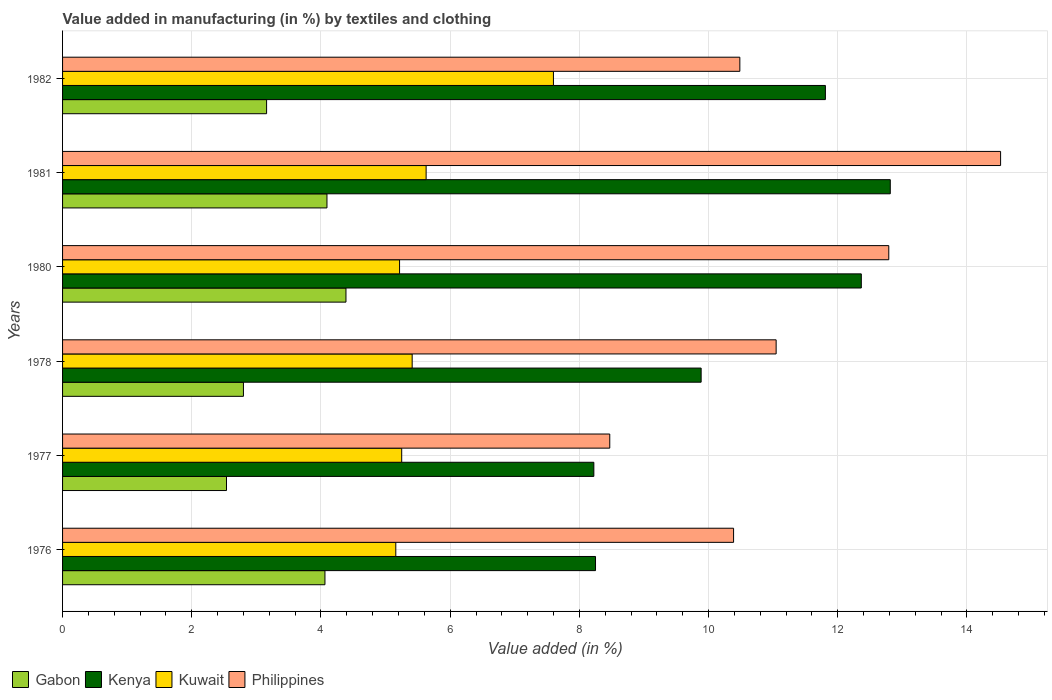Are the number of bars per tick equal to the number of legend labels?
Give a very brief answer. Yes. Are the number of bars on each tick of the Y-axis equal?
Your answer should be compact. Yes. What is the label of the 1st group of bars from the top?
Your answer should be very brief. 1982. What is the percentage of value added in manufacturing by textiles and clothing in Kenya in 1981?
Give a very brief answer. 12.81. Across all years, what is the maximum percentage of value added in manufacturing by textiles and clothing in Gabon?
Provide a short and direct response. 4.39. Across all years, what is the minimum percentage of value added in manufacturing by textiles and clothing in Philippines?
Keep it short and to the point. 8.47. In which year was the percentage of value added in manufacturing by textiles and clothing in Kuwait minimum?
Provide a short and direct response. 1976. What is the total percentage of value added in manufacturing by textiles and clothing in Kenya in the graph?
Ensure brevity in your answer.  63.34. What is the difference between the percentage of value added in manufacturing by textiles and clothing in Kuwait in 1981 and that in 1982?
Keep it short and to the point. -1.97. What is the difference between the percentage of value added in manufacturing by textiles and clothing in Kenya in 1978 and the percentage of value added in manufacturing by textiles and clothing in Gabon in 1976?
Ensure brevity in your answer.  5.82. What is the average percentage of value added in manufacturing by textiles and clothing in Kenya per year?
Provide a succinct answer. 10.56. In the year 1981, what is the difference between the percentage of value added in manufacturing by textiles and clothing in Kuwait and percentage of value added in manufacturing by textiles and clothing in Kenya?
Offer a terse response. -7.19. In how many years, is the percentage of value added in manufacturing by textiles and clothing in Kenya greater than 13.2 %?
Keep it short and to the point. 0. What is the ratio of the percentage of value added in manufacturing by textiles and clothing in Philippines in 1977 to that in 1978?
Provide a succinct answer. 0.77. Is the difference between the percentage of value added in manufacturing by textiles and clothing in Kuwait in 1981 and 1982 greater than the difference between the percentage of value added in manufacturing by textiles and clothing in Kenya in 1981 and 1982?
Keep it short and to the point. No. What is the difference between the highest and the second highest percentage of value added in manufacturing by textiles and clothing in Kenya?
Your answer should be very brief. 0.45. What is the difference between the highest and the lowest percentage of value added in manufacturing by textiles and clothing in Gabon?
Give a very brief answer. 1.85. What does the 3rd bar from the top in 1981 represents?
Ensure brevity in your answer.  Kenya. What does the 1st bar from the bottom in 1982 represents?
Your answer should be compact. Gabon. Is it the case that in every year, the sum of the percentage of value added in manufacturing by textiles and clothing in Gabon and percentage of value added in manufacturing by textiles and clothing in Kuwait is greater than the percentage of value added in manufacturing by textiles and clothing in Kenya?
Your answer should be compact. No. Are all the bars in the graph horizontal?
Make the answer very short. Yes. How many years are there in the graph?
Your answer should be compact. 6. What is the difference between two consecutive major ticks on the X-axis?
Give a very brief answer. 2. Are the values on the major ticks of X-axis written in scientific E-notation?
Give a very brief answer. No. Does the graph contain any zero values?
Your answer should be very brief. No. Does the graph contain grids?
Keep it short and to the point. Yes. Where does the legend appear in the graph?
Make the answer very short. Bottom left. How many legend labels are there?
Offer a very short reply. 4. How are the legend labels stacked?
Provide a short and direct response. Horizontal. What is the title of the graph?
Keep it short and to the point. Value added in manufacturing (in %) by textiles and clothing. Does "Finland" appear as one of the legend labels in the graph?
Provide a short and direct response. No. What is the label or title of the X-axis?
Ensure brevity in your answer.  Value added (in %). What is the Value added (in %) in Gabon in 1976?
Keep it short and to the point. 4.06. What is the Value added (in %) in Kenya in 1976?
Your answer should be very brief. 8.25. What is the Value added (in %) of Kuwait in 1976?
Provide a succinct answer. 5.16. What is the Value added (in %) of Philippines in 1976?
Your answer should be compact. 10.39. What is the Value added (in %) of Gabon in 1977?
Make the answer very short. 2.54. What is the Value added (in %) in Kenya in 1977?
Your answer should be very brief. 8.22. What is the Value added (in %) in Kuwait in 1977?
Make the answer very short. 5.25. What is the Value added (in %) in Philippines in 1977?
Offer a very short reply. 8.47. What is the Value added (in %) of Gabon in 1978?
Provide a short and direct response. 2.8. What is the Value added (in %) in Kenya in 1978?
Offer a terse response. 9.88. What is the Value added (in %) in Kuwait in 1978?
Ensure brevity in your answer.  5.41. What is the Value added (in %) in Philippines in 1978?
Your answer should be compact. 11.05. What is the Value added (in %) of Gabon in 1980?
Your answer should be compact. 4.39. What is the Value added (in %) of Kenya in 1980?
Give a very brief answer. 12.36. What is the Value added (in %) in Kuwait in 1980?
Your response must be concise. 5.22. What is the Value added (in %) of Philippines in 1980?
Make the answer very short. 12.79. What is the Value added (in %) of Gabon in 1981?
Your answer should be very brief. 4.09. What is the Value added (in %) in Kenya in 1981?
Keep it short and to the point. 12.81. What is the Value added (in %) in Kuwait in 1981?
Offer a very short reply. 5.63. What is the Value added (in %) in Philippines in 1981?
Offer a terse response. 14.52. What is the Value added (in %) in Gabon in 1982?
Your response must be concise. 3.16. What is the Value added (in %) in Kenya in 1982?
Give a very brief answer. 11.81. What is the Value added (in %) of Kuwait in 1982?
Keep it short and to the point. 7.6. What is the Value added (in %) in Philippines in 1982?
Ensure brevity in your answer.  10.48. Across all years, what is the maximum Value added (in %) of Gabon?
Give a very brief answer. 4.39. Across all years, what is the maximum Value added (in %) in Kenya?
Your response must be concise. 12.81. Across all years, what is the maximum Value added (in %) of Kuwait?
Your answer should be compact. 7.6. Across all years, what is the maximum Value added (in %) in Philippines?
Ensure brevity in your answer.  14.52. Across all years, what is the minimum Value added (in %) in Gabon?
Your answer should be compact. 2.54. Across all years, what is the minimum Value added (in %) in Kenya?
Your answer should be compact. 8.22. Across all years, what is the minimum Value added (in %) in Kuwait?
Your response must be concise. 5.16. Across all years, what is the minimum Value added (in %) of Philippines?
Ensure brevity in your answer.  8.47. What is the total Value added (in %) of Gabon in the graph?
Offer a very short reply. 21.04. What is the total Value added (in %) of Kenya in the graph?
Make the answer very short. 63.34. What is the total Value added (in %) of Kuwait in the graph?
Offer a very short reply. 34.26. What is the total Value added (in %) in Philippines in the graph?
Provide a short and direct response. 67.7. What is the difference between the Value added (in %) of Gabon in 1976 and that in 1977?
Provide a short and direct response. 1.52. What is the difference between the Value added (in %) of Kenya in 1976 and that in 1977?
Give a very brief answer. 0.03. What is the difference between the Value added (in %) in Kuwait in 1976 and that in 1977?
Offer a very short reply. -0.09. What is the difference between the Value added (in %) in Philippines in 1976 and that in 1977?
Offer a terse response. 1.92. What is the difference between the Value added (in %) of Gabon in 1976 and that in 1978?
Ensure brevity in your answer.  1.26. What is the difference between the Value added (in %) in Kenya in 1976 and that in 1978?
Keep it short and to the point. -1.63. What is the difference between the Value added (in %) of Kuwait in 1976 and that in 1978?
Your response must be concise. -0.25. What is the difference between the Value added (in %) of Philippines in 1976 and that in 1978?
Your answer should be very brief. -0.66. What is the difference between the Value added (in %) in Gabon in 1976 and that in 1980?
Your answer should be compact. -0.33. What is the difference between the Value added (in %) of Kenya in 1976 and that in 1980?
Ensure brevity in your answer.  -4.11. What is the difference between the Value added (in %) of Kuwait in 1976 and that in 1980?
Keep it short and to the point. -0.06. What is the difference between the Value added (in %) in Philippines in 1976 and that in 1980?
Provide a short and direct response. -2.4. What is the difference between the Value added (in %) of Gabon in 1976 and that in 1981?
Provide a short and direct response. -0.03. What is the difference between the Value added (in %) in Kenya in 1976 and that in 1981?
Give a very brief answer. -4.56. What is the difference between the Value added (in %) of Kuwait in 1976 and that in 1981?
Your response must be concise. -0.47. What is the difference between the Value added (in %) of Philippines in 1976 and that in 1981?
Provide a succinct answer. -4.13. What is the difference between the Value added (in %) of Gabon in 1976 and that in 1982?
Your answer should be very brief. 0.9. What is the difference between the Value added (in %) of Kenya in 1976 and that in 1982?
Provide a short and direct response. -3.56. What is the difference between the Value added (in %) of Kuwait in 1976 and that in 1982?
Keep it short and to the point. -2.44. What is the difference between the Value added (in %) of Philippines in 1976 and that in 1982?
Provide a succinct answer. -0.1. What is the difference between the Value added (in %) of Gabon in 1977 and that in 1978?
Offer a terse response. -0.26. What is the difference between the Value added (in %) in Kenya in 1977 and that in 1978?
Your response must be concise. -1.66. What is the difference between the Value added (in %) of Kuwait in 1977 and that in 1978?
Give a very brief answer. -0.16. What is the difference between the Value added (in %) of Philippines in 1977 and that in 1978?
Make the answer very short. -2.58. What is the difference between the Value added (in %) of Gabon in 1977 and that in 1980?
Your answer should be compact. -1.85. What is the difference between the Value added (in %) in Kenya in 1977 and that in 1980?
Make the answer very short. -4.14. What is the difference between the Value added (in %) in Kuwait in 1977 and that in 1980?
Your answer should be compact. 0.03. What is the difference between the Value added (in %) of Philippines in 1977 and that in 1980?
Provide a short and direct response. -4.32. What is the difference between the Value added (in %) of Gabon in 1977 and that in 1981?
Make the answer very short. -1.56. What is the difference between the Value added (in %) in Kenya in 1977 and that in 1981?
Your response must be concise. -4.59. What is the difference between the Value added (in %) in Kuwait in 1977 and that in 1981?
Your answer should be very brief. -0.38. What is the difference between the Value added (in %) of Philippines in 1977 and that in 1981?
Provide a succinct answer. -6.05. What is the difference between the Value added (in %) in Gabon in 1977 and that in 1982?
Provide a short and direct response. -0.62. What is the difference between the Value added (in %) of Kenya in 1977 and that in 1982?
Provide a succinct answer. -3.58. What is the difference between the Value added (in %) in Kuwait in 1977 and that in 1982?
Give a very brief answer. -2.35. What is the difference between the Value added (in %) in Philippines in 1977 and that in 1982?
Provide a short and direct response. -2.01. What is the difference between the Value added (in %) of Gabon in 1978 and that in 1980?
Provide a short and direct response. -1.59. What is the difference between the Value added (in %) in Kenya in 1978 and that in 1980?
Your response must be concise. -2.48. What is the difference between the Value added (in %) of Kuwait in 1978 and that in 1980?
Keep it short and to the point. 0.2. What is the difference between the Value added (in %) in Philippines in 1978 and that in 1980?
Provide a succinct answer. -1.74. What is the difference between the Value added (in %) in Gabon in 1978 and that in 1981?
Provide a short and direct response. -1.29. What is the difference between the Value added (in %) of Kenya in 1978 and that in 1981?
Your answer should be very brief. -2.93. What is the difference between the Value added (in %) of Kuwait in 1978 and that in 1981?
Ensure brevity in your answer.  -0.22. What is the difference between the Value added (in %) in Philippines in 1978 and that in 1981?
Your answer should be compact. -3.47. What is the difference between the Value added (in %) of Gabon in 1978 and that in 1982?
Give a very brief answer. -0.36. What is the difference between the Value added (in %) in Kenya in 1978 and that in 1982?
Give a very brief answer. -1.92. What is the difference between the Value added (in %) in Kuwait in 1978 and that in 1982?
Your response must be concise. -2.19. What is the difference between the Value added (in %) in Philippines in 1978 and that in 1982?
Provide a succinct answer. 0.56. What is the difference between the Value added (in %) of Gabon in 1980 and that in 1981?
Give a very brief answer. 0.29. What is the difference between the Value added (in %) of Kenya in 1980 and that in 1981?
Your answer should be very brief. -0.45. What is the difference between the Value added (in %) in Kuwait in 1980 and that in 1981?
Provide a succinct answer. -0.41. What is the difference between the Value added (in %) of Philippines in 1980 and that in 1981?
Your answer should be compact. -1.73. What is the difference between the Value added (in %) in Gabon in 1980 and that in 1982?
Ensure brevity in your answer.  1.23. What is the difference between the Value added (in %) of Kenya in 1980 and that in 1982?
Offer a very short reply. 0.56. What is the difference between the Value added (in %) of Kuwait in 1980 and that in 1982?
Your response must be concise. -2.38. What is the difference between the Value added (in %) in Philippines in 1980 and that in 1982?
Give a very brief answer. 2.31. What is the difference between the Value added (in %) of Gabon in 1981 and that in 1982?
Keep it short and to the point. 0.93. What is the difference between the Value added (in %) in Kenya in 1981 and that in 1982?
Keep it short and to the point. 1. What is the difference between the Value added (in %) in Kuwait in 1981 and that in 1982?
Your answer should be compact. -1.97. What is the difference between the Value added (in %) of Philippines in 1981 and that in 1982?
Provide a short and direct response. 4.04. What is the difference between the Value added (in %) of Gabon in 1976 and the Value added (in %) of Kenya in 1977?
Your response must be concise. -4.16. What is the difference between the Value added (in %) in Gabon in 1976 and the Value added (in %) in Kuwait in 1977?
Keep it short and to the point. -1.19. What is the difference between the Value added (in %) of Gabon in 1976 and the Value added (in %) of Philippines in 1977?
Provide a succinct answer. -4.41. What is the difference between the Value added (in %) in Kenya in 1976 and the Value added (in %) in Kuwait in 1977?
Your answer should be compact. 3. What is the difference between the Value added (in %) in Kenya in 1976 and the Value added (in %) in Philippines in 1977?
Ensure brevity in your answer.  -0.22. What is the difference between the Value added (in %) in Kuwait in 1976 and the Value added (in %) in Philippines in 1977?
Your response must be concise. -3.31. What is the difference between the Value added (in %) in Gabon in 1976 and the Value added (in %) in Kenya in 1978?
Your response must be concise. -5.82. What is the difference between the Value added (in %) of Gabon in 1976 and the Value added (in %) of Kuwait in 1978?
Offer a very short reply. -1.35. What is the difference between the Value added (in %) in Gabon in 1976 and the Value added (in %) in Philippines in 1978?
Provide a short and direct response. -6.98. What is the difference between the Value added (in %) in Kenya in 1976 and the Value added (in %) in Kuwait in 1978?
Provide a succinct answer. 2.84. What is the difference between the Value added (in %) of Kenya in 1976 and the Value added (in %) of Philippines in 1978?
Give a very brief answer. -2.8. What is the difference between the Value added (in %) of Kuwait in 1976 and the Value added (in %) of Philippines in 1978?
Keep it short and to the point. -5.89. What is the difference between the Value added (in %) of Gabon in 1976 and the Value added (in %) of Kenya in 1980?
Keep it short and to the point. -8.3. What is the difference between the Value added (in %) of Gabon in 1976 and the Value added (in %) of Kuwait in 1980?
Ensure brevity in your answer.  -1.15. What is the difference between the Value added (in %) of Gabon in 1976 and the Value added (in %) of Philippines in 1980?
Provide a succinct answer. -8.73. What is the difference between the Value added (in %) in Kenya in 1976 and the Value added (in %) in Kuwait in 1980?
Keep it short and to the point. 3.03. What is the difference between the Value added (in %) of Kenya in 1976 and the Value added (in %) of Philippines in 1980?
Offer a terse response. -4.54. What is the difference between the Value added (in %) of Kuwait in 1976 and the Value added (in %) of Philippines in 1980?
Make the answer very short. -7.63. What is the difference between the Value added (in %) in Gabon in 1976 and the Value added (in %) in Kenya in 1981?
Provide a short and direct response. -8.75. What is the difference between the Value added (in %) of Gabon in 1976 and the Value added (in %) of Kuwait in 1981?
Ensure brevity in your answer.  -1.57. What is the difference between the Value added (in %) of Gabon in 1976 and the Value added (in %) of Philippines in 1981?
Keep it short and to the point. -10.46. What is the difference between the Value added (in %) of Kenya in 1976 and the Value added (in %) of Kuwait in 1981?
Offer a terse response. 2.62. What is the difference between the Value added (in %) in Kenya in 1976 and the Value added (in %) in Philippines in 1981?
Provide a short and direct response. -6.27. What is the difference between the Value added (in %) of Kuwait in 1976 and the Value added (in %) of Philippines in 1981?
Make the answer very short. -9.36. What is the difference between the Value added (in %) of Gabon in 1976 and the Value added (in %) of Kenya in 1982?
Ensure brevity in your answer.  -7.75. What is the difference between the Value added (in %) in Gabon in 1976 and the Value added (in %) in Kuwait in 1982?
Your answer should be very brief. -3.54. What is the difference between the Value added (in %) in Gabon in 1976 and the Value added (in %) in Philippines in 1982?
Offer a very short reply. -6.42. What is the difference between the Value added (in %) of Kenya in 1976 and the Value added (in %) of Kuwait in 1982?
Your answer should be compact. 0.65. What is the difference between the Value added (in %) of Kenya in 1976 and the Value added (in %) of Philippines in 1982?
Your response must be concise. -2.23. What is the difference between the Value added (in %) in Kuwait in 1976 and the Value added (in %) in Philippines in 1982?
Offer a terse response. -5.33. What is the difference between the Value added (in %) of Gabon in 1977 and the Value added (in %) of Kenya in 1978?
Make the answer very short. -7.35. What is the difference between the Value added (in %) of Gabon in 1977 and the Value added (in %) of Kuwait in 1978?
Make the answer very short. -2.87. What is the difference between the Value added (in %) of Gabon in 1977 and the Value added (in %) of Philippines in 1978?
Offer a very short reply. -8.51. What is the difference between the Value added (in %) in Kenya in 1977 and the Value added (in %) in Kuwait in 1978?
Your response must be concise. 2.81. What is the difference between the Value added (in %) of Kenya in 1977 and the Value added (in %) of Philippines in 1978?
Your response must be concise. -2.82. What is the difference between the Value added (in %) of Kuwait in 1977 and the Value added (in %) of Philippines in 1978?
Give a very brief answer. -5.8. What is the difference between the Value added (in %) in Gabon in 1977 and the Value added (in %) in Kenya in 1980?
Ensure brevity in your answer.  -9.83. What is the difference between the Value added (in %) in Gabon in 1977 and the Value added (in %) in Kuwait in 1980?
Your response must be concise. -2.68. What is the difference between the Value added (in %) of Gabon in 1977 and the Value added (in %) of Philippines in 1980?
Offer a terse response. -10.25. What is the difference between the Value added (in %) of Kenya in 1977 and the Value added (in %) of Kuwait in 1980?
Provide a short and direct response. 3.01. What is the difference between the Value added (in %) in Kenya in 1977 and the Value added (in %) in Philippines in 1980?
Provide a succinct answer. -4.57. What is the difference between the Value added (in %) in Kuwait in 1977 and the Value added (in %) in Philippines in 1980?
Your answer should be very brief. -7.54. What is the difference between the Value added (in %) in Gabon in 1977 and the Value added (in %) in Kenya in 1981?
Your answer should be compact. -10.28. What is the difference between the Value added (in %) in Gabon in 1977 and the Value added (in %) in Kuwait in 1981?
Your answer should be compact. -3.09. What is the difference between the Value added (in %) in Gabon in 1977 and the Value added (in %) in Philippines in 1981?
Keep it short and to the point. -11.98. What is the difference between the Value added (in %) of Kenya in 1977 and the Value added (in %) of Kuwait in 1981?
Provide a succinct answer. 2.6. What is the difference between the Value added (in %) of Kenya in 1977 and the Value added (in %) of Philippines in 1981?
Make the answer very short. -6.3. What is the difference between the Value added (in %) in Kuwait in 1977 and the Value added (in %) in Philippines in 1981?
Keep it short and to the point. -9.27. What is the difference between the Value added (in %) of Gabon in 1977 and the Value added (in %) of Kenya in 1982?
Your answer should be compact. -9.27. What is the difference between the Value added (in %) of Gabon in 1977 and the Value added (in %) of Kuwait in 1982?
Your answer should be very brief. -5.06. What is the difference between the Value added (in %) in Gabon in 1977 and the Value added (in %) in Philippines in 1982?
Provide a short and direct response. -7.95. What is the difference between the Value added (in %) of Kenya in 1977 and the Value added (in %) of Kuwait in 1982?
Ensure brevity in your answer.  0.63. What is the difference between the Value added (in %) of Kenya in 1977 and the Value added (in %) of Philippines in 1982?
Your answer should be very brief. -2.26. What is the difference between the Value added (in %) in Kuwait in 1977 and the Value added (in %) in Philippines in 1982?
Offer a terse response. -5.23. What is the difference between the Value added (in %) in Gabon in 1978 and the Value added (in %) in Kenya in 1980?
Give a very brief answer. -9.56. What is the difference between the Value added (in %) of Gabon in 1978 and the Value added (in %) of Kuwait in 1980?
Provide a short and direct response. -2.42. What is the difference between the Value added (in %) of Gabon in 1978 and the Value added (in %) of Philippines in 1980?
Provide a succinct answer. -9.99. What is the difference between the Value added (in %) of Kenya in 1978 and the Value added (in %) of Kuwait in 1980?
Offer a terse response. 4.67. What is the difference between the Value added (in %) of Kenya in 1978 and the Value added (in %) of Philippines in 1980?
Provide a succinct answer. -2.9. What is the difference between the Value added (in %) in Kuwait in 1978 and the Value added (in %) in Philippines in 1980?
Offer a very short reply. -7.38. What is the difference between the Value added (in %) of Gabon in 1978 and the Value added (in %) of Kenya in 1981?
Keep it short and to the point. -10.01. What is the difference between the Value added (in %) in Gabon in 1978 and the Value added (in %) in Kuwait in 1981?
Your response must be concise. -2.83. What is the difference between the Value added (in %) in Gabon in 1978 and the Value added (in %) in Philippines in 1981?
Your answer should be very brief. -11.72. What is the difference between the Value added (in %) in Kenya in 1978 and the Value added (in %) in Kuwait in 1981?
Your answer should be very brief. 4.26. What is the difference between the Value added (in %) of Kenya in 1978 and the Value added (in %) of Philippines in 1981?
Keep it short and to the point. -4.64. What is the difference between the Value added (in %) of Kuwait in 1978 and the Value added (in %) of Philippines in 1981?
Make the answer very short. -9.11. What is the difference between the Value added (in %) of Gabon in 1978 and the Value added (in %) of Kenya in 1982?
Make the answer very short. -9.01. What is the difference between the Value added (in %) in Gabon in 1978 and the Value added (in %) in Kuwait in 1982?
Give a very brief answer. -4.8. What is the difference between the Value added (in %) of Gabon in 1978 and the Value added (in %) of Philippines in 1982?
Provide a succinct answer. -7.68. What is the difference between the Value added (in %) of Kenya in 1978 and the Value added (in %) of Kuwait in 1982?
Make the answer very short. 2.29. What is the difference between the Value added (in %) of Kenya in 1978 and the Value added (in %) of Philippines in 1982?
Provide a short and direct response. -0.6. What is the difference between the Value added (in %) of Kuwait in 1978 and the Value added (in %) of Philippines in 1982?
Your answer should be compact. -5.07. What is the difference between the Value added (in %) in Gabon in 1980 and the Value added (in %) in Kenya in 1981?
Your response must be concise. -8.43. What is the difference between the Value added (in %) of Gabon in 1980 and the Value added (in %) of Kuwait in 1981?
Ensure brevity in your answer.  -1.24. What is the difference between the Value added (in %) in Gabon in 1980 and the Value added (in %) in Philippines in 1981?
Keep it short and to the point. -10.13. What is the difference between the Value added (in %) of Kenya in 1980 and the Value added (in %) of Kuwait in 1981?
Offer a terse response. 6.74. What is the difference between the Value added (in %) of Kenya in 1980 and the Value added (in %) of Philippines in 1981?
Offer a terse response. -2.16. What is the difference between the Value added (in %) of Kuwait in 1980 and the Value added (in %) of Philippines in 1981?
Your response must be concise. -9.3. What is the difference between the Value added (in %) of Gabon in 1980 and the Value added (in %) of Kenya in 1982?
Offer a very short reply. -7.42. What is the difference between the Value added (in %) of Gabon in 1980 and the Value added (in %) of Kuwait in 1982?
Make the answer very short. -3.21. What is the difference between the Value added (in %) of Gabon in 1980 and the Value added (in %) of Philippines in 1982?
Offer a terse response. -6.1. What is the difference between the Value added (in %) of Kenya in 1980 and the Value added (in %) of Kuwait in 1982?
Your response must be concise. 4.77. What is the difference between the Value added (in %) in Kenya in 1980 and the Value added (in %) in Philippines in 1982?
Keep it short and to the point. 1.88. What is the difference between the Value added (in %) in Kuwait in 1980 and the Value added (in %) in Philippines in 1982?
Provide a succinct answer. -5.27. What is the difference between the Value added (in %) of Gabon in 1981 and the Value added (in %) of Kenya in 1982?
Provide a succinct answer. -7.72. What is the difference between the Value added (in %) in Gabon in 1981 and the Value added (in %) in Kuwait in 1982?
Provide a short and direct response. -3.51. What is the difference between the Value added (in %) in Gabon in 1981 and the Value added (in %) in Philippines in 1982?
Your answer should be compact. -6.39. What is the difference between the Value added (in %) of Kenya in 1981 and the Value added (in %) of Kuwait in 1982?
Offer a very short reply. 5.21. What is the difference between the Value added (in %) in Kenya in 1981 and the Value added (in %) in Philippines in 1982?
Keep it short and to the point. 2.33. What is the difference between the Value added (in %) in Kuwait in 1981 and the Value added (in %) in Philippines in 1982?
Make the answer very short. -4.86. What is the average Value added (in %) in Gabon per year?
Provide a succinct answer. 3.51. What is the average Value added (in %) of Kenya per year?
Offer a terse response. 10.56. What is the average Value added (in %) in Kuwait per year?
Offer a terse response. 5.71. What is the average Value added (in %) in Philippines per year?
Keep it short and to the point. 11.28. In the year 1976, what is the difference between the Value added (in %) of Gabon and Value added (in %) of Kenya?
Keep it short and to the point. -4.19. In the year 1976, what is the difference between the Value added (in %) in Gabon and Value added (in %) in Kuwait?
Keep it short and to the point. -1.1. In the year 1976, what is the difference between the Value added (in %) in Gabon and Value added (in %) in Philippines?
Provide a succinct answer. -6.33. In the year 1976, what is the difference between the Value added (in %) in Kenya and Value added (in %) in Kuwait?
Provide a succinct answer. 3.09. In the year 1976, what is the difference between the Value added (in %) of Kenya and Value added (in %) of Philippines?
Provide a succinct answer. -2.14. In the year 1976, what is the difference between the Value added (in %) of Kuwait and Value added (in %) of Philippines?
Offer a terse response. -5.23. In the year 1977, what is the difference between the Value added (in %) of Gabon and Value added (in %) of Kenya?
Your answer should be very brief. -5.69. In the year 1977, what is the difference between the Value added (in %) of Gabon and Value added (in %) of Kuwait?
Your response must be concise. -2.71. In the year 1977, what is the difference between the Value added (in %) in Gabon and Value added (in %) in Philippines?
Your response must be concise. -5.93. In the year 1977, what is the difference between the Value added (in %) in Kenya and Value added (in %) in Kuwait?
Your response must be concise. 2.97. In the year 1977, what is the difference between the Value added (in %) in Kenya and Value added (in %) in Philippines?
Provide a succinct answer. -0.25. In the year 1977, what is the difference between the Value added (in %) in Kuwait and Value added (in %) in Philippines?
Provide a succinct answer. -3.22. In the year 1978, what is the difference between the Value added (in %) of Gabon and Value added (in %) of Kenya?
Keep it short and to the point. -7.08. In the year 1978, what is the difference between the Value added (in %) of Gabon and Value added (in %) of Kuwait?
Provide a short and direct response. -2.61. In the year 1978, what is the difference between the Value added (in %) in Gabon and Value added (in %) in Philippines?
Your answer should be very brief. -8.25. In the year 1978, what is the difference between the Value added (in %) of Kenya and Value added (in %) of Kuwait?
Provide a succinct answer. 4.47. In the year 1978, what is the difference between the Value added (in %) of Kenya and Value added (in %) of Philippines?
Provide a succinct answer. -1.16. In the year 1978, what is the difference between the Value added (in %) in Kuwait and Value added (in %) in Philippines?
Offer a terse response. -5.63. In the year 1980, what is the difference between the Value added (in %) of Gabon and Value added (in %) of Kenya?
Your answer should be compact. -7.98. In the year 1980, what is the difference between the Value added (in %) of Gabon and Value added (in %) of Kuwait?
Keep it short and to the point. -0.83. In the year 1980, what is the difference between the Value added (in %) of Gabon and Value added (in %) of Philippines?
Offer a terse response. -8.4. In the year 1980, what is the difference between the Value added (in %) in Kenya and Value added (in %) in Kuwait?
Your response must be concise. 7.15. In the year 1980, what is the difference between the Value added (in %) in Kenya and Value added (in %) in Philippines?
Provide a short and direct response. -0.43. In the year 1980, what is the difference between the Value added (in %) in Kuwait and Value added (in %) in Philippines?
Offer a terse response. -7.57. In the year 1981, what is the difference between the Value added (in %) in Gabon and Value added (in %) in Kenya?
Keep it short and to the point. -8.72. In the year 1981, what is the difference between the Value added (in %) in Gabon and Value added (in %) in Kuwait?
Your response must be concise. -1.53. In the year 1981, what is the difference between the Value added (in %) of Gabon and Value added (in %) of Philippines?
Make the answer very short. -10.43. In the year 1981, what is the difference between the Value added (in %) of Kenya and Value added (in %) of Kuwait?
Offer a very short reply. 7.19. In the year 1981, what is the difference between the Value added (in %) in Kenya and Value added (in %) in Philippines?
Offer a very short reply. -1.71. In the year 1981, what is the difference between the Value added (in %) in Kuwait and Value added (in %) in Philippines?
Your answer should be compact. -8.89. In the year 1982, what is the difference between the Value added (in %) in Gabon and Value added (in %) in Kenya?
Give a very brief answer. -8.65. In the year 1982, what is the difference between the Value added (in %) of Gabon and Value added (in %) of Kuwait?
Offer a terse response. -4.44. In the year 1982, what is the difference between the Value added (in %) in Gabon and Value added (in %) in Philippines?
Provide a succinct answer. -7.33. In the year 1982, what is the difference between the Value added (in %) of Kenya and Value added (in %) of Kuwait?
Offer a very short reply. 4.21. In the year 1982, what is the difference between the Value added (in %) of Kenya and Value added (in %) of Philippines?
Your response must be concise. 1.32. In the year 1982, what is the difference between the Value added (in %) of Kuwait and Value added (in %) of Philippines?
Your answer should be compact. -2.89. What is the ratio of the Value added (in %) of Gabon in 1976 to that in 1977?
Your response must be concise. 1.6. What is the ratio of the Value added (in %) of Kenya in 1976 to that in 1977?
Give a very brief answer. 1. What is the ratio of the Value added (in %) in Kuwait in 1976 to that in 1977?
Your answer should be compact. 0.98. What is the ratio of the Value added (in %) of Philippines in 1976 to that in 1977?
Offer a terse response. 1.23. What is the ratio of the Value added (in %) of Gabon in 1976 to that in 1978?
Offer a very short reply. 1.45. What is the ratio of the Value added (in %) in Kenya in 1976 to that in 1978?
Your answer should be very brief. 0.83. What is the ratio of the Value added (in %) in Kuwait in 1976 to that in 1978?
Your response must be concise. 0.95. What is the ratio of the Value added (in %) in Philippines in 1976 to that in 1978?
Give a very brief answer. 0.94. What is the ratio of the Value added (in %) in Gabon in 1976 to that in 1980?
Your answer should be very brief. 0.93. What is the ratio of the Value added (in %) of Kenya in 1976 to that in 1980?
Offer a very short reply. 0.67. What is the ratio of the Value added (in %) of Philippines in 1976 to that in 1980?
Your answer should be very brief. 0.81. What is the ratio of the Value added (in %) of Gabon in 1976 to that in 1981?
Give a very brief answer. 0.99. What is the ratio of the Value added (in %) of Kenya in 1976 to that in 1981?
Your response must be concise. 0.64. What is the ratio of the Value added (in %) of Kuwait in 1976 to that in 1981?
Provide a succinct answer. 0.92. What is the ratio of the Value added (in %) in Philippines in 1976 to that in 1981?
Provide a short and direct response. 0.72. What is the ratio of the Value added (in %) in Gabon in 1976 to that in 1982?
Your response must be concise. 1.29. What is the ratio of the Value added (in %) of Kenya in 1976 to that in 1982?
Offer a terse response. 0.7. What is the ratio of the Value added (in %) in Kuwait in 1976 to that in 1982?
Offer a terse response. 0.68. What is the ratio of the Value added (in %) in Gabon in 1977 to that in 1978?
Provide a short and direct response. 0.91. What is the ratio of the Value added (in %) in Kenya in 1977 to that in 1978?
Provide a short and direct response. 0.83. What is the ratio of the Value added (in %) in Kuwait in 1977 to that in 1978?
Offer a terse response. 0.97. What is the ratio of the Value added (in %) of Philippines in 1977 to that in 1978?
Provide a short and direct response. 0.77. What is the ratio of the Value added (in %) in Gabon in 1977 to that in 1980?
Keep it short and to the point. 0.58. What is the ratio of the Value added (in %) of Kenya in 1977 to that in 1980?
Offer a very short reply. 0.67. What is the ratio of the Value added (in %) of Kuwait in 1977 to that in 1980?
Offer a very short reply. 1.01. What is the ratio of the Value added (in %) of Philippines in 1977 to that in 1980?
Keep it short and to the point. 0.66. What is the ratio of the Value added (in %) in Gabon in 1977 to that in 1981?
Offer a very short reply. 0.62. What is the ratio of the Value added (in %) of Kenya in 1977 to that in 1981?
Offer a very short reply. 0.64. What is the ratio of the Value added (in %) of Kuwait in 1977 to that in 1981?
Give a very brief answer. 0.93. What is the ratio of the Value added (in %) of Philippines in 1977 to that in 1981?
Make the answer very short. 0.58. What is the ratio of the Value added (in %) in Gabon in 1977 to that in 1982?
Give a very brief answer. 0.8. What is the ratio of the Value added (in %) of Kenya in 1977 to that in 1982?
Your answer should be very brief. 0.7. What is the ratio of the Value added (in %) in Kuwait in 1977 to that in 1982?
Provide a short and direct response. 0.69. What is the ratio of the Value added (in %) in Philippines in 1977 to that in 1982?
Your answer should be very brief. 0.81. What is the ratio of the Value added (in %) in Gabon in 1978 to that in 1980?
Ensure brevity in your answer.  0.64. What is the ratio of the Value added (in %) in Kenya in 1978 to that in 1980?
Ensure brevity in your answer.  0.8. What is the ratio of the Value added (in %) in Kuwait in 1978 to that in 1980?
Ensure brevity in your answer.  1.04. What is the ratio of the Value added (in %) of Philippines in 1978 to that in 1980?
Give a very brief answer. 0.86. What is the ratio of the Value added (in %) in Gabon in 1978 to that in 1981?
Offer a very short reply. 0.68. What is the ratio of the Value added (in %) in Kenya in 1978 to that in 1981?
Provide a short and direct response. 0.77. What is the ratio of the Value added (in %) in Kuwait in 1978 to that in 1981?
Offer a very short reply. 0.96. What is the ratio of the Value added (in %) of Philippines in 1978 to that in 1981?
Make the answer very short. 0.76. What is the ratio of the Value added (in %) of Gabon in 1978 to that in 1982?
Provide a succinct answer. 0.89. What is the ratio of the Value added (in %) of Kenya in 1978 to that in 1982?
Keep it short and to the point. 0.84. What is the ratio of the Value added (in %) of Kuwait in 1978 to that in 1982?
Offer a very short reply. 0.71. What is the ratio of the Value added (in %) in Philippines in 1978 to that in 1982?
Provide a short and direct response. 1.05. What is the ratio of the Value added (in %) in Gabon in 1980 to that in 1981?
Ensure brevity in your answer.  1.07. What is the ratio of the Value added (in %) of Kuwait in 1980 to that in 1981?
Make the answer very short. 0.93. What is the ratio of the Value added (in %) of Philippines in 1980 to that in 1981?
Your answer should be very brief. 0.88. What is the ratio of the Value added (in %) in Gabon in 1980 to that in 1982?
Your answer should be very brief. 1.39. What is the ratio of the Value added (in %) of Kenya in 1980 to that in 1982?
Provide a short and direct response. 1.05. What is the ratio of the Value added (in %) of Kuwait in 1980 to that in 1982?
Offer a terse response. 0.69. What is the ratio of the Value added (in %) in Philippines in 1980 to that in 1982?
Provide a short and direct response. 1.22. What is the ratio of the Value added (in %) in Gabon in 1981 to that in 1982?
Your response must be concise. 1.3. What is the ratio of the Value added (in %) in Kenya in 1981 to that in 1982?
Give a very brief answer. 1.09. What is the ratio of the Value added (in %) in Kuwait in 1981 to that in 1982?
Keep it short and to the point. 0.74. What is the ratio of the Value added (in %) in Philippines in 1981 to that in 1982?
Your answer should be very brief. 1.39. What is the difference between the highest and the second highest Value added (in %) of Gabon?
Your response must be concise. 0.29. What is the difference between the highest and the second highest Value added (in %) of Kenya?
Ensure brevity in your answer.  0.45. What is the difference between the highest and the second highest Value added (in %) of Kuwait?
Keep it short and to the point. 1.97. What is the difference between the highest and the second highest Value added (in %) of Philippines?
Your answer should be very brief. 1.73. What is the difference between the highest and the lowest Value added (in %) of Gabon?
Provide a short and direct response. 1.85. What is the difference between the highest and the lowest Value added (in %) in Kenya?
Keep it short and to the point. 4.59. What is the difference between the highest and the lowest Value added (in %) of Kuwait?
Your answer should be very brief. 2.44. What is the difference between the highest and the lowest Value added (in %) in Philippines?
Ensure brevity in your answer.  6.05. 